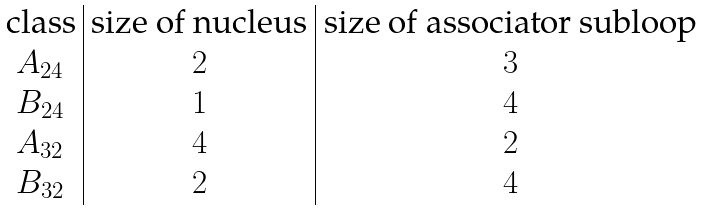<formula> <loc_0><loc_0><loc_500><loc_500>\begin{array} { c | c | c } \text {class} & \text {size of nucleus} & \text {size of associator subloop} \\ A _ { 2 4 } & 2 & 3 \\ B _ { 2 4 } & 1 & 4 \\ A _ { 3 2 } & 4 & 2 \\ B _ { 3 2 } & 2 & 4 \end{array}</formula> 